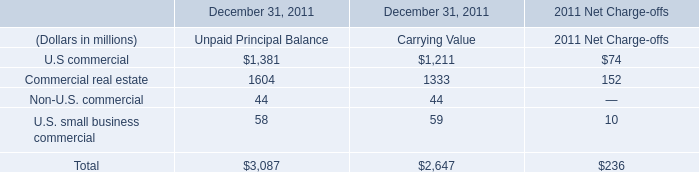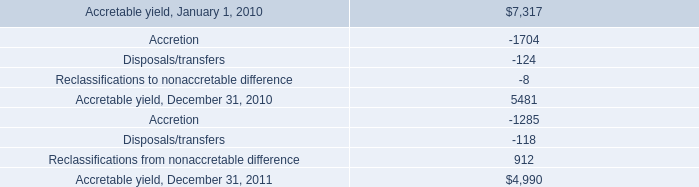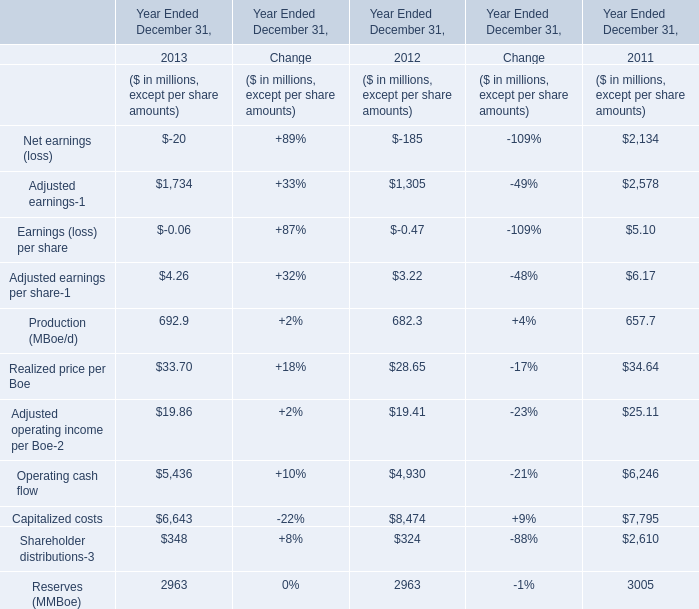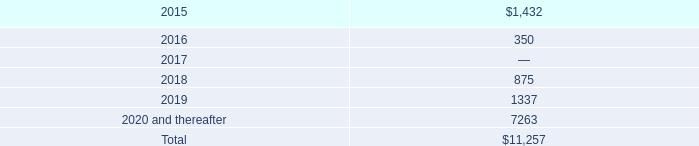What is the average amount of U.S commercial of December 31, 2011 Unpaid Principal Balance, and Accretable yield, January 1, 2010 ? 
Computations: ((1381.0 + 7317.0) / 2)
Answer: 4349.0. 